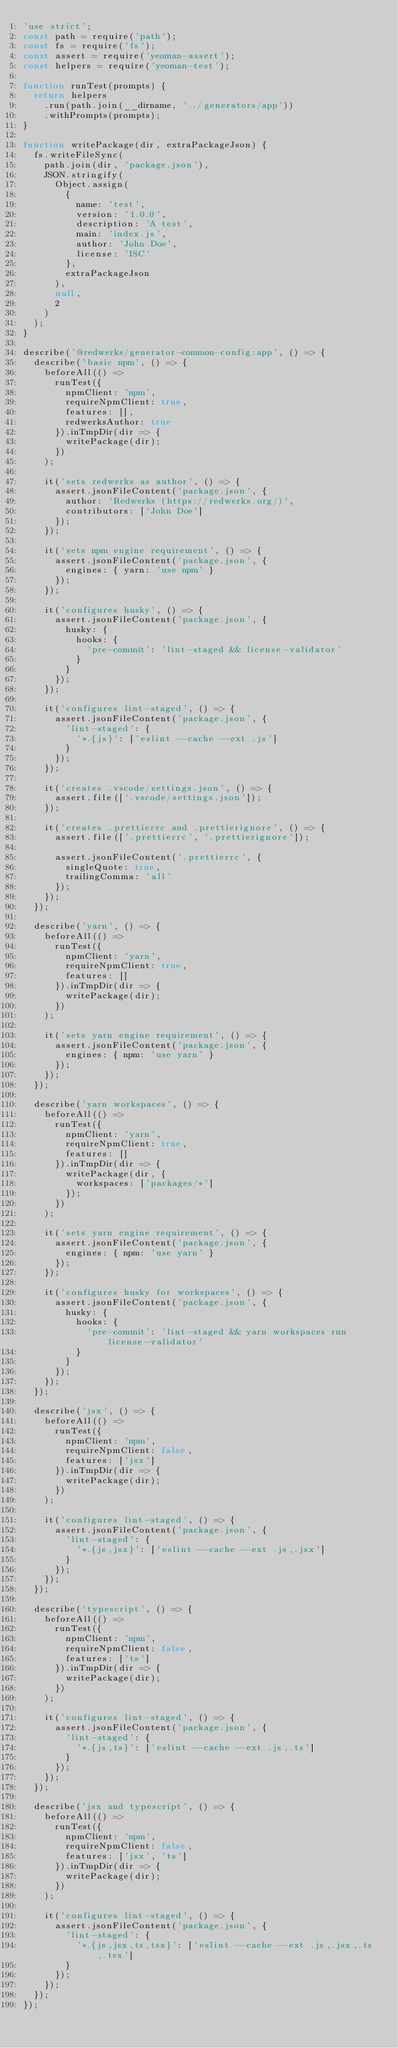Convert code to text. <code><loc_0><loc_0><loc_500><loc_500><_JavaScript_>'use strict';
const path = require('path');
const fs = require('fs');
const assert = require('yeoman-assert');
const helpers = require('yeoman-test');

function runTest(prompts) {
  return helpers
    .run(path.join(__dirname, '../generators/app'))
    .withPrompts(prompts);
}

function writePackage(dir, extraPackageJson) {
  fs.writeFileSync(
    path.join(dir, 'package.json'),
    JSON.stringify(
      Object.assign(
        {
          name: 'test',
          version: '1.0.0',
          description: 'A test',
          main: 'index.js',
          author: 'John Doe',
          license: 'ISC'
        },
        extraPackageJson
      ),
      null,
      2
    )
  );
}

describe('@redwerks/generator-common-config:app', () => {
  describe('basic npm', () => {
    beforeAll(() =>
      runTest({
        npmClient: 'npm',
        requireNpmClient: true,
        features: [],
        redwerksAuthor: true
      }).inTmpDir(dir => {
        writePackage(dir);
      })
    );

    it('sets redwerks as author', () => {
      assert.jsonFileContent('package.json', {
        author: 'Redwerks (https://redwerks.org/)',
        contributors: ['John Doe']
      });
    });

    it('sets npm engine requirement', () => {
      assert.jsonFileContent('package.json', {
        engines: { yarn: 'use npm' }
      });
    });

    it('configures husky', () => {
      assert.jsonFileContent('package.json', {
        husky: {
          hooks: {
            'pre-commit': 'lint-staged && license-validator'
          }
        }
      });
    });

    it('configures lint-staged', () => {
      assert.jsonFileContent('package.json', {
        'lint-staged': {
          '*.{js}': ['eslint --cache --ext .js']
        }
      });
    });

    it('creates .vscode/settings.json', () => {
      assert.file(['.vscode/settings.json']);
    });

    it('creates .prettierrc and .prettierignore', () => {
      assert.file(['.prettierrc', '.prettierignore']);

      assert.jsonFileContent('.prettierrc', {
        singleQuote: true,
        trailingComma: 'all'
      });
    });
  });

  describe('yarn', () => {
    beforeAll(() =>
      runTest({
        npmClient: 'yarn',
        requireNpmClient: true,
        features: []
      }).inTmpDir(dir => {
        writePackage(dir);
      })
    );

    it('sets yarn engine requirement', () => {
      assert.jsonFileContent('package.json', {
        engines: { npm: 'use yarn' }
      });
    });
  });

  describe('yarn workspaces', () => {
    beforeAll(() =>
      runTest({
        npmClient: 'yarn',
        requireNpmClient: true,
        features: []
      }).inTmpDir(dir => {
        writePackage(dir, {
          workspaces: ['packages/*']
        });
      })
    );

    it('sets yarn engine requirement', () => {
      assert.jsonFileContent('package.json', {
        engines: { npm: 'use yarn' }
      });
    });

    it('configures husky for workspaces', () => {
      assert.jsonFileContent('package.json', {
        husky: {
          hooks: {
            'pre-commit': 'lint-staged && yarn workspaces run license-validator'
          }
        }
      });
    });
  });

  describe('jsx', () => {
    beforeAll(() =>
      runTest({
        npmClient: 'npm',
        requireNpmClient: false,
        features: ['jsx']
      }).inTmpDir(dir => {
        writePackage(dir);
      })
    );

    it('configures lint-staged', () => {
      assert.jsonFileContent('package.json', {
        'lint-staged': {
          '*.{js,jsx}': ['eslint --cache --ext .js,.jsx']
        }
      });
    });
  });

  describe('typescript', () => {
    beforeAll(() =>
      runTest({
        npmClient: 'npm',
        requireNpmClient: false,
        features: ['ts']
      }).inTmpDir(dir => {
        writePackage(dir);
      })
    );

    it('configures lint-staged', () => {
      assert.jsonFileContent('package.json', {
        'lint-staged': {
          '*.{js,ts}': ['eslint --cache --ext .js,.ts']
        }
      });
    });
  });

  describe('jsx and typescript', () => {
    beforeAll(() =>
      runTest({
        npmClient: 'npm',
        requireNpmClient: false,
        features: ['jsx', 'ts']
      }).inTmpDir(dir => {
        writePackage(dir);
      })
    );

    it('configures lint-staged', () => {
      assert.jsonFileContent('package.json', {
        'lint-staged': {
          '*.{js,jsx,ts,tsx}': ['eslint --cache --ext .js,.jsx,.ts,.tsx']
        }
      });
    });
  });
});
</code> 